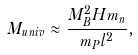<formula> <loc_0><loc_0><loc_500><loc_500>M _ { u n i v } \approx \frac { M ^ { 2 } _ { B } H m _ { n } } { m _ { P } l ^ { 2 } } ,</formula> 